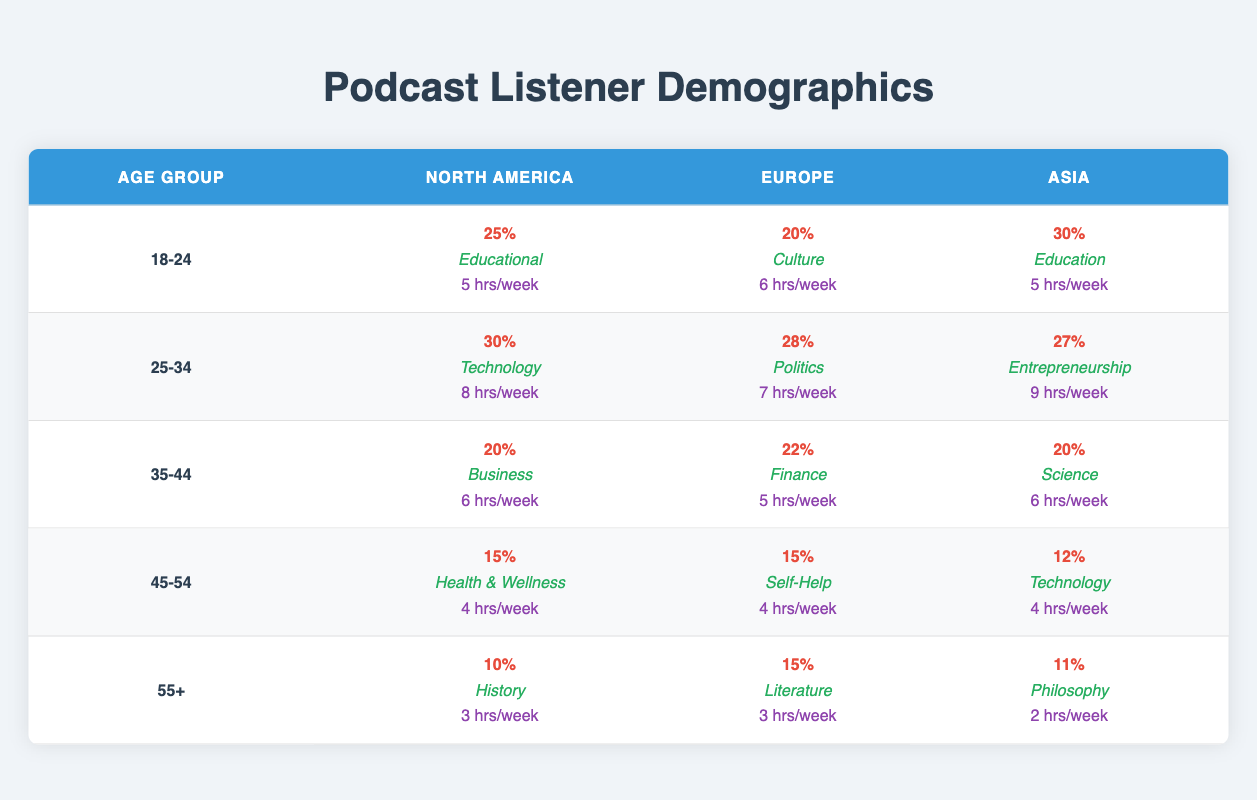What is the top podcast genre for the age group 25-34 in North America? According to the table, the top podcast genre for the age group 25-34 in North America is Technology.
Answer: Technology What percentage of listeners aged 18-24 in Asia listen to podcasts? In the table, the percentage of listeners aged 18-24 in Asia is listed as 30%.
Answer: 30% Which age group has the lowest average listening hours per week in Europe? For Europe, the age group 55+ has the lowest average listening hours per week, which is 3 hours.
Answer: 55+ What is the difference in podcast listening percentages between the age groups 45-54 and 55+ in North America? In North America, the percentage for age group 45-54 is 15%, and for 55+, it is 10%. The difference is 15% - 10% = 5%.
Answer: 5% Is the average listening time for listeners in Asia aged 45-54 higher than for those in North America aged 45-54? In Asia, the average listening time for 45-54 is 4 hours, while for North America, it is also 4 hours. Therefore, it is false that it is higher.
Answer: No What is the average percentage of listeners across all age groups in Europe? The percentages for Europe are 20, 28, 22, 15, and 15. Summing these gives 100, and dividing by 5 gives an average of 20%.
Answer: 20% Which age group in North America shows the highest podcast listening percentage? North America has the highest podcast listening percentage in the age group 25-34, which is 30%.
Answer: 25-34 What is the total percentage of listeners aged 35-44 across all regions? The percentages for 35-44 are 20% (North America), 22% (Europe), and 20% (Asia). Thus, total percentage = 20% + 22% + 20% = 62%.
Answer: 62% In which region do the listeners aged 55+ have the highest percentage? For listeners aged 55+, the percentages are 10% (North America), 15% (Europe), and 11% (Asia). The highest is in Europe, at 15%.
Answer: Europe What podcast genre is most popular among listeners aged 45-54 in Asia? According to the table, the top podcast genre for listeners aged 45-54 in Asia is Technology.
Answer: Technology Are listeners aged 18-24 in Europe more inclined towards educational content than their counterparts in North America? In Europe, the top podcast genre for 18-24 is Culture, while in North America it is Educational. Therefore, listeners in Europe are not more inclined towards educational content.
Answer: No 